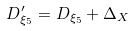Convert formula to latex. <formula><loc_0><loc_0><loc_500><loc_500>D _ { \xi _ { 5 } } ^ { \prime } = D _ { \xi _ { 5 } } + \Delta _ { X }</formula> 